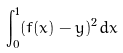<formula> <loc_0><loc_0><loc_500><loc_500>\int _ { 0 } ^ { 1 } ( f ( x ) - y ) ^ { 2 } d x</formula> 